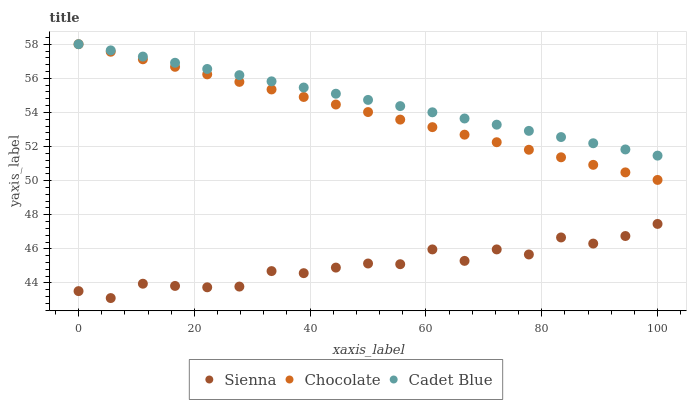Does Sienna have the minimum area under the curve?
Answer yes or no. Yes. Does Cadet Blue have the maximum area under the curve?
Answer yes or no. Yes. Does Chocolate have the minimum area under the curve?
Answer yes or no. No. Does Chocolate have the maximum area under the curve?
Answer yes or no. No. Is Cadet Blue the smoothest?
Answer yes or no. Yes. Is Sienna the roughest?
Answer yes or no. Yes. Is Chocolate the smoothest?
Answer yes or no. No. Is Chocolate the roughest?
Answer yes or no. No. Does Sienna have the lowest value?
Answer yes or no. Yes. Does Chocolate have the lowest value?
Answer yes or no. No. Does Chocolate have the highest value?
Answer yes or no. Yes. Is Sienna less than Chocolate?
Answer yes or no. Yes. Is Chocolate greater than Sienna?
Answer yes or no. Yes. Does Chocolate intersect Cadet Blue?
Answer yes or no. Yes. Is Chocolate less than Cadet Blue?
Answer yes or no. No. Is Chocolate greater than Cadet Blue?
Answer yes or no. No. Does Sienna intersect Chocolate?
Answer yes or no. No. 